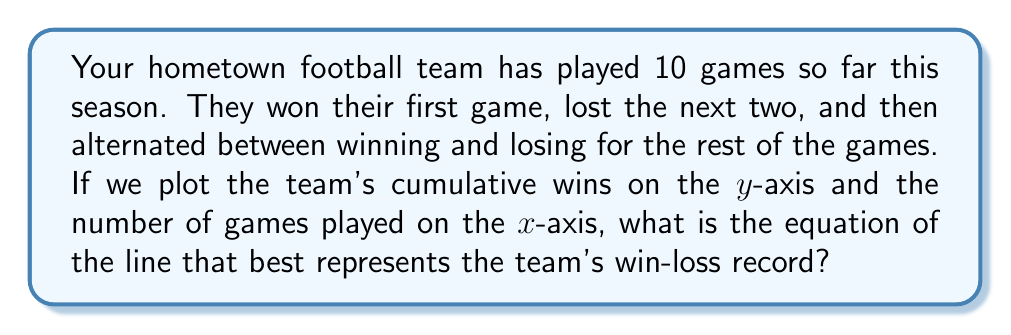What is the answer to this math problem? Let's approach this step-by-step:

1) First, let's visualize the data:
   Game 1: Win (1-0)
   Game 2: Loss (1-1)
   Game 3: Loss (1-2)
   Game 4: Win (2-2)
   Game 5: Loss (2-3)
   Game 6: Win (3-3)
   Game 7: Loss (3-4)
   Game 8: Win (4-4)
   Game 9: Loss (4-5)
   Game 10: Win (5-5)

2) We can see that after the first three games, the team alternates between winning and losing. This creates a pattern where they win every other game.

3) To find the equation of the line, we need two points. Let's use the first game (1, 1) and the last game (10, 5) as our two points.

4) The slope-intercept form of a line is $y = mx + b$, where $m$ is the slope and $b$ is the y-intercept.

5) To find the slope $m$:
   $m = \frac{y_2 - y_1}{x_2 - x_1} = \frac{5 - 1}{10 - 1} = \frac{4}{9} \approx 0.444$

6) Now that we have the slope, we can use either point to find $b$. Let's use (1, 1):
   $1 = \frac{4}{9}(1) + b$
   $b = 1 - \frac{4}{9} = \frac{5}{9} \approx 0.556$

7) Therefore, the equation of the line is:
   $y = \frac{4}{9}x + \frac{5}{9}$

This line represents the team's average win rate over the course of the season.
Answer: The equation of the line representing the team's win-loss record is $y = \frac{4}{9}x + \frac{5}{9}$. 